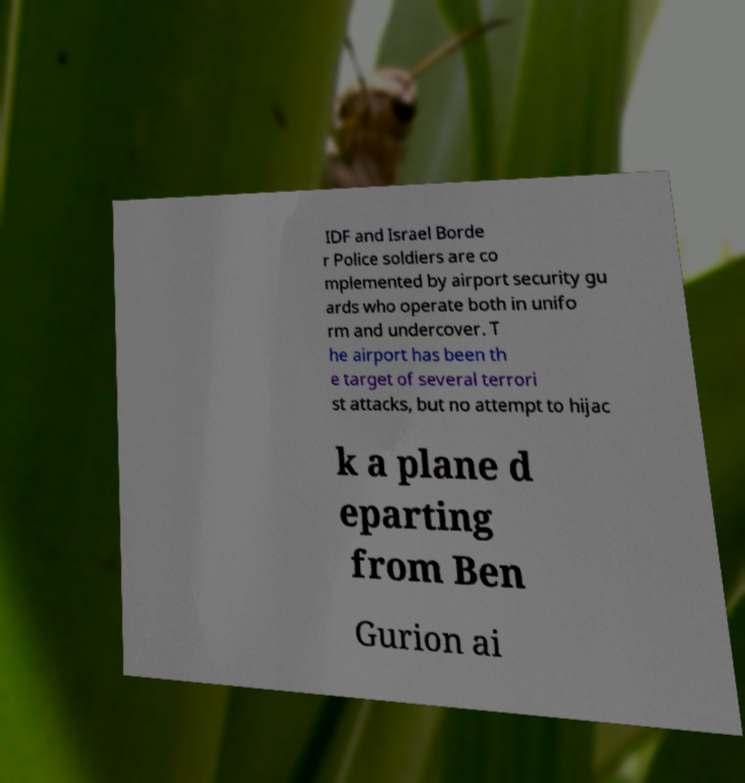I need the written content from this picture converted into text. Can you do that? IDF and Israel Borde r Police soldiers are co mplemented by airport security gu ards who operate both in unifo rm and undercover. T he airport has been th e target of several terrori st attacks, but no attempt to hijac k a plane d eparting from Ben Gurion ai 